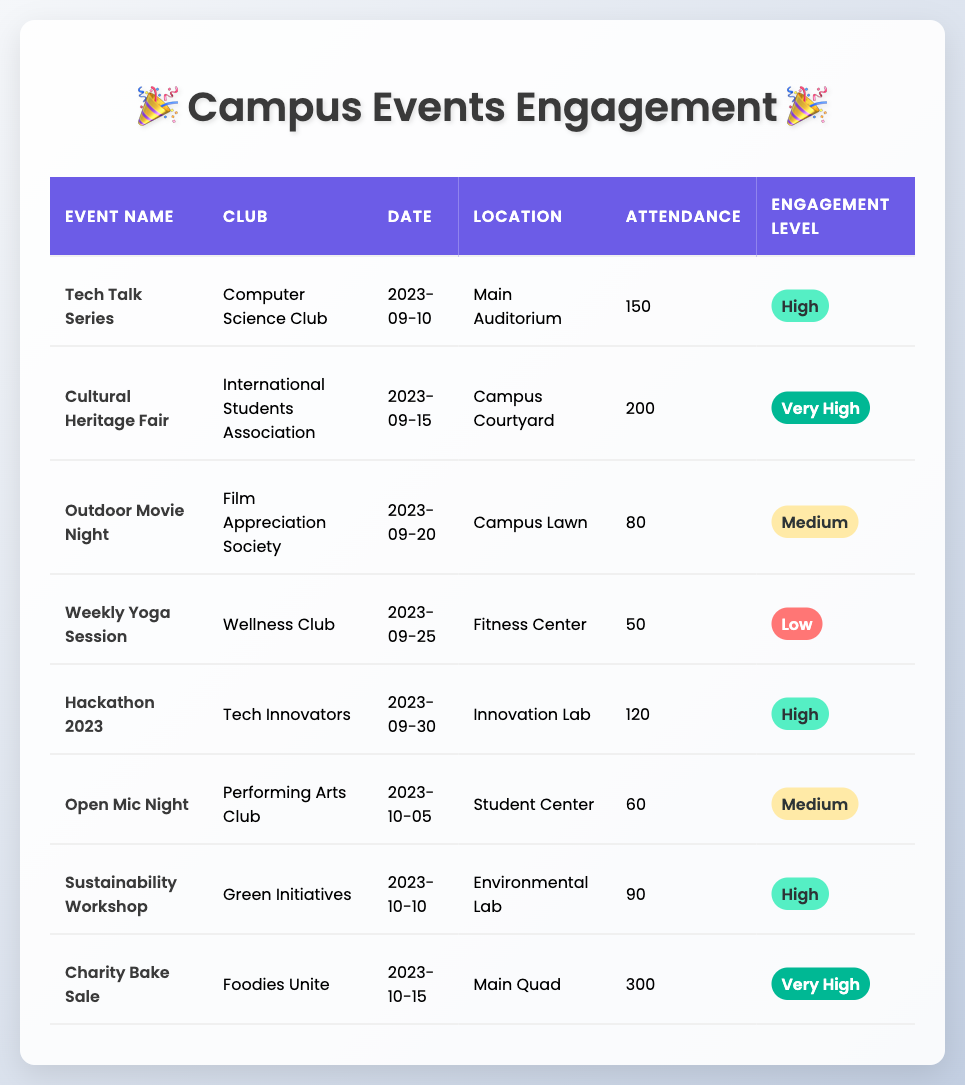What is the location of the "Hackathon 2023"? The table shows that the "Hackathon 2023" is located in the "Innovation Lab".
Answer: Innovation Lab How many attendees were present at the "Cultural Heritage Fair"? The attendance for the "Cultural Heritage Fair" is listed in the table as 200.
Answer: 200 What is the engagement level for the "Weekly Yoga Session"? According to the table, the engagement level for the "Weekly Yoga Session" is marked as "Low".
Answer: Low Which club had the highest attendance at their event? The "Charity Bake Sale" organized by "Foodies Unite" had the highest attendance of 300.
Answer: Foodies Unite What was the average attendance of events categorized as "High" engagement? The events with "High" engagement are "Tech Talk Series" (150), "Hackathon 2023" (120), and "Sustainability Workshop" (90). The sum of their attendance is 150 + 120 + 90 = 360. There are 3 events, so the average attendance is 360/3 = 120.
Answer: 120 Is there any event with a "Medium" engagement level that had more than 70 attendees? Yes, both the "Outdoor Movie Night" (80 attendees) and "Open Mic Night" (60 attendees) are marked as "Medium," but only the Outdoor Movie Night has more than 70 attendees.
Answer: Yes How many events had an engagement level of "Very High"? The table lists two events: "Cultural Heritage Fair" and "Charity Bake Sale" as having a "Very High" engagement level.
Answer: 2 What was the date of the "Outdoor Movie Night"? The table indicates that the "Outdoor Movie Night" took place on "2023-09-20".
Answer: 2023-09-20 If the attendance at the "Weekly Yoga Session" were to increase by 30, what would its new attendance be? The current attendance for the "Weekly Yoga Session" is 50. If 30 are added, the new attendance would be 50 + 30 = 80.
Answer: 80 